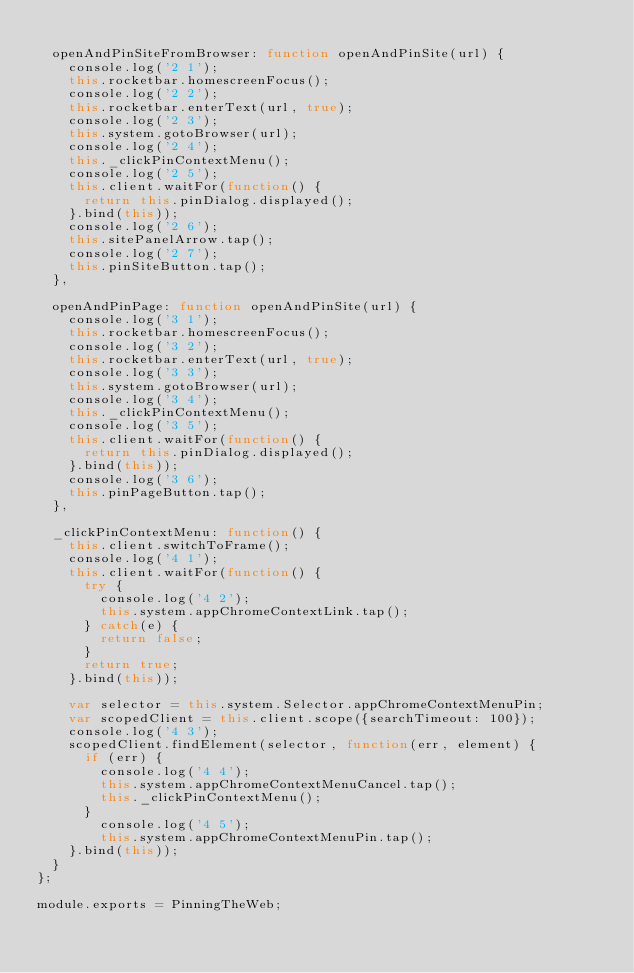Convert code to text. <code><loc_0><loc_0><loc_500><loc_500><_JavaScript_>
  openAndPinSiteFromBrowser: function openAndPinSite(url) {
    console.log('2 1');
    this.rocketbar.homescreenFocus();
    console.log('2 2');
    this.rocketbar.enterText(url, true);
    console.log('2 3');
    this.system.gotoBrowser(url);
    console.log('2 4');
    this._clickPinContextMenu();
    console.log('2 5');
    this.client.waitFor(function() {
      return this.pinDialog.displayed();
    }.bind(this));
    console.log('2 6');
    this.sitePanelArrow.tap();
    console.log('2 7');
    this.pinSiteButton.tap();
  },

  openAndPinPage: function openAndPinSite(url) {
    console.log('3 1');
    this.rocketbar.homescreenFocus();
    console.log('3 2');
    this.rocketbar.enterText(url, true);
    console.log('3 3');
    this.system.gotoBrowser(url);
    console.log('3 4');
    this._clickPinContextMenu();
    console.log('3 5');
    this.client.waitFor(function() {
      return this.pinDialog.displayed();
    }.bind(this));
    console.log('3 6');
    this.pinPageButton.tap();
  },

  _clickPinContextMenu: function() {
    this.client.switchToFrame();
    console.log('4 1');
    this.client.waitFor(function() {
      try {
        console.log('4 2');
        this.system.appChromeContextLink.tap();
      } catch(e) {
        return false;
      }
      return true;
    }.bind(this));

    var selector = this.system.Selector.appChromeContextMenuPin;
    var scopedClient = this.client.scope({searchTimeout: 100});
    console.log('4 3');
    scopedClient.findElement(selector, function(err, element) {
      if (err) {
        console.log('4 4');
        this.system.appChromeContextMenuCancel.tap();
        this._clickPinContextMenu();
      }
        console.log('4 5');
        this.system.appChromeContextMenuPin.tap();
    }.bind(this));
  }
};

module.exports = PinningTheWeb;
</code> 